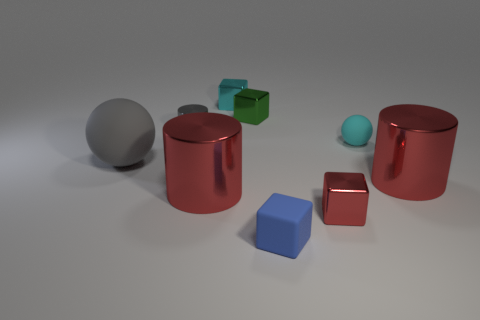There is a tiny metallic thing that is both in front of the green cube and behind the small red shiny object; what is its color?
Your response must be concise. Gray. How many big rubber things are left of the metal block in front of the big rubber sphere?
Provide a short and direct response. 1. There is a small green thing that is the same shape as the small blue thing; what material is it?
Offer a very short reply. Metal. The big matte ball has what color?
Your answer should be compact. Gray. How many objects are either big shiny things or large gray cylinders?
Make the answer very short. 2. What is the shape of the gray object that is behind the rubber ball that is left of the green shiny object?
Ensure brevity in your answer.  Cylinder. How many other objects are the same material as the tiny gray thing?
Provide a succinct answer. 5. Is the material of the small blue thing the same as the small cyan thing that is to the right of the small rubber block?
Make the answer very short. Yes. How many objects are big red metallic cylinders that are to the left of the blue matte cube or big cylinders on the left side of the tiny red metallic object?
Your answer should be compact. 1. How many other objects are the same color as the big ball?
Offer a terse response. 1. 